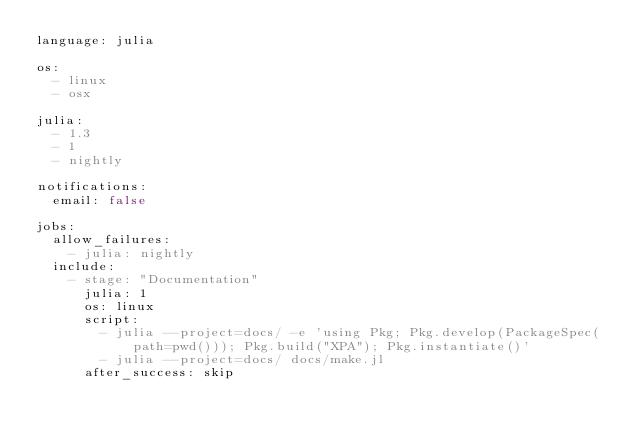<code> <loc_0><loc_0><loc_500><loc_500><_YAML_>language: julia

os:
  - linux
  - osx

julia:
  - 1.3
  - 1
  - nightly

notifications:
  email: false

jobs:
  allow_failures:
    - julia: nightly
  include:
    - stage: "Documentation"
      julia: 1
      os: linux
      script:
        - julia --project=docs/ -e 'using Pkg; Pkg.develop(PackageSpec(path=pwd())); Pkg.build("XPA"); Pkg.instantiate()'
        - julia --project=docs/ docs/make.jl
      after_success: skip
</code> 